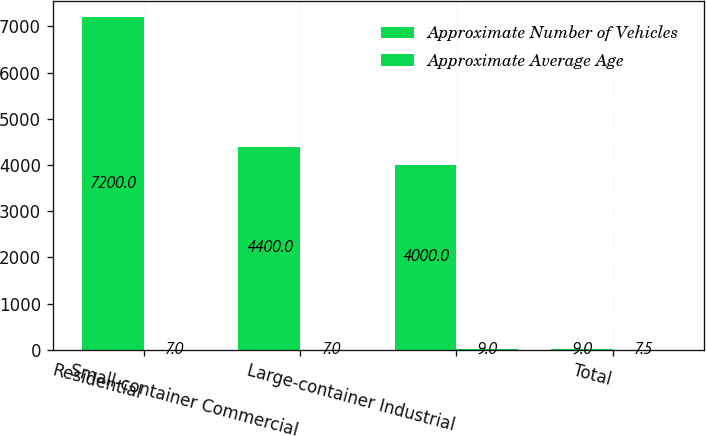Convert chart to OTSL. <chart><loc_0><loc_0><loc_500><loc_500><stacked_bar_chart><ecel><fcel>Residential<fcel>Small-container Commercial<fcel>Large-container Industrial<fcel>Total<nl><fcel>Approximate Number of Vehicles<fcel>7200<fcel>4400<fcel>4000<fcel>9<nl><fcel>Approximate Average Age<fcel>7<fcel>7<fcel>9<fcel>7.5<nl></chart> 